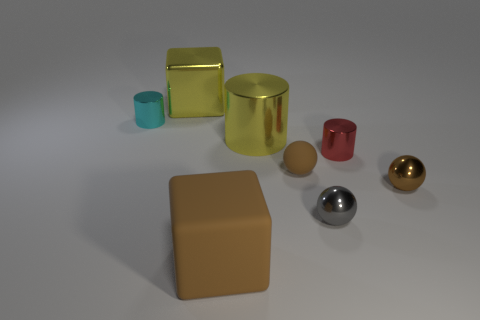What number of other objects are there of the same color as the big metallic block?
Your answer should be very brief. 1. What number of brown things are rubber objects or small cylinders?
Offer a terse response. 2. There is a small cyan metal object; is it the same shape as the yellow thing behind the small cyan cylinder?
Offer a very short reply. No. The big brown object has what shape?
Offer a very short reply. Cube. There is another cylinder that is the same size as the cyan metal cylinder; what is its material?
Your answer should be very brief. Metal. What number of objects are big brown cubes or big rubber blocks on the left side of the tiny brown rubber object?
Your response must be concise. 1. There is a yellow thing that is the same material as the yellow cylinder; what is its size?
Give a very brief answer. Large. What is the shape of the large shiny thing that is behind the cyan object that is to the left of the brown cube?
Offer a very short reply. Cube. There is a metallic object that is in front of the big cylinder and on the left side of the red cylinder; what size is it?
Offer a terse response. Small. Are there any small cyan shiny objects that have the same shape as the red shiny object?
Your answer should be compact. Yes. 